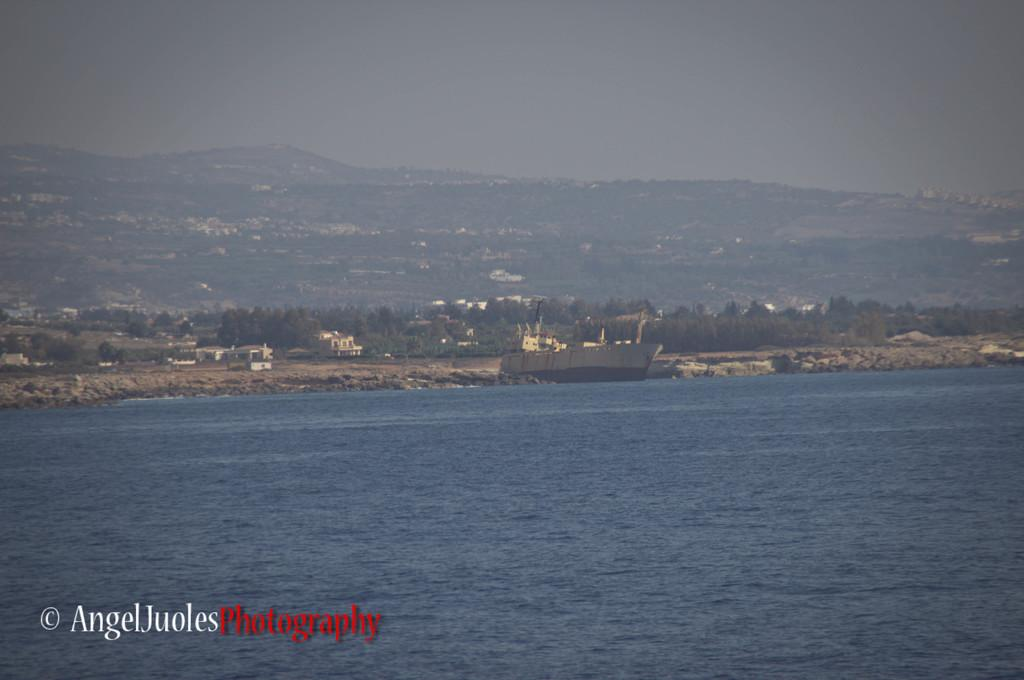What is the main subject of the image? There is a ship in the image. Where is the ship located? The ship is on the water. What other elements can be seen in the image? There are buildings, trees, hills, and the sky visible in the image. What type of corn can be seen growing on the glass in the image? There is no corn or glass present in the image. Can you tell me how many requests are being made in the image? There is no indication of any requests being made in the image. 